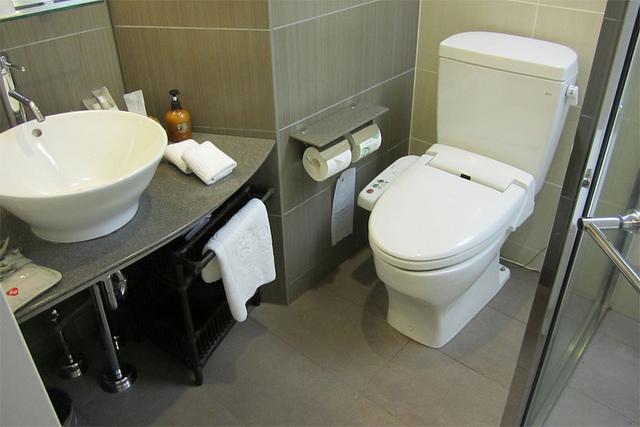What color is the toilet?
Give a very brief answer. White. Is this a public restroom?
Answer briefly. No. Does this toilet have buttons?
Answer briefly. Yes. What's the majority color of this room?
Short answer required. Gray. 